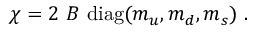Convert formula to latex. <formula><loc_0><loc_0><loc_500><loc_500>\chi = 2 \ B \ d i a g ( m _ { u } , m _ { d } , m _ { s } ) \ .</formula> 